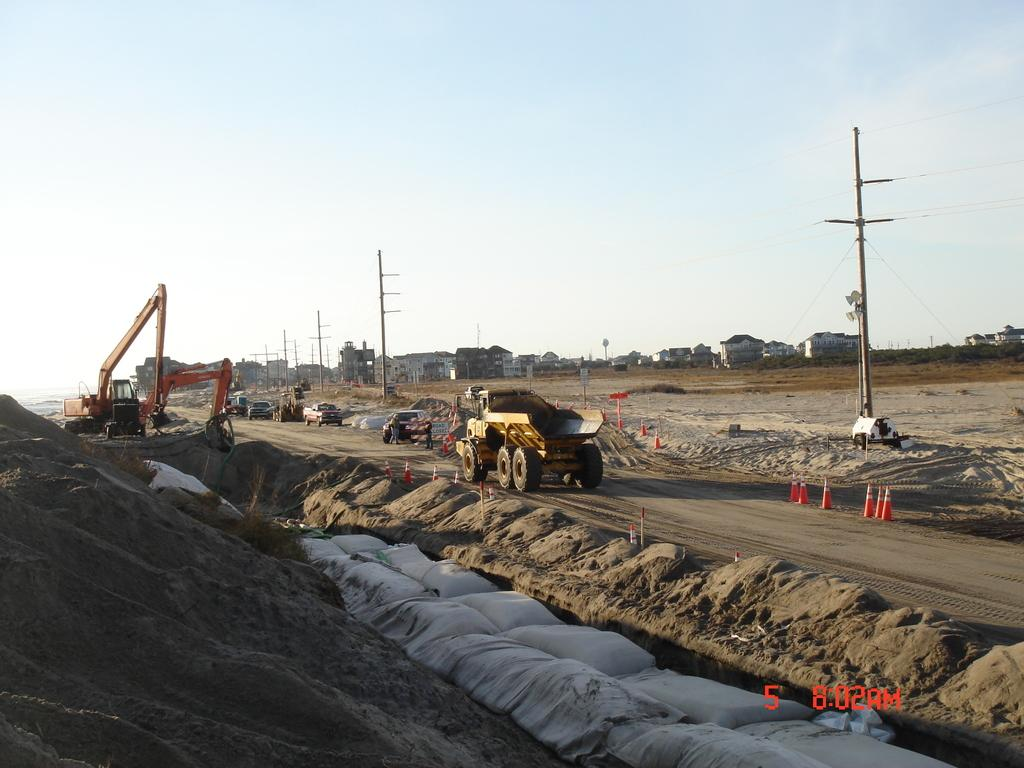What types of vehicles are in the image? There are vehicles in the image, but the specific types are not mentioned. What else can be seen in the image besides vehicles? There are poles and traffic cones in the image. What is the general setting of the image? There are buildings in the background of the image, and the sky is visible in the background. Can you describe the objects in the image? There are objects in the image, but their specific nature is not mentioned. What type of string is being used to ask a question in the image? There is no string or question present in the image. What is the edge of the image used for? The edge of the image is not a part of the image itself; it is a property of the medium on which the image is displayed. 